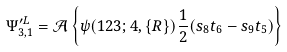<formula> <loc_0><loc_0><loc_500><loc_500>\Psi _ { 3 , 1 } ^ { \prime L } = \mathcal { A } \left \{ \psi ( 1 2 3 ; 4 , \{ { R } \} ) \frac { 1 } { 2 } ( s _ { 8 } t _ { 6 } - s _ { 9 } t _ { 5 } ) \right \}</formula> 